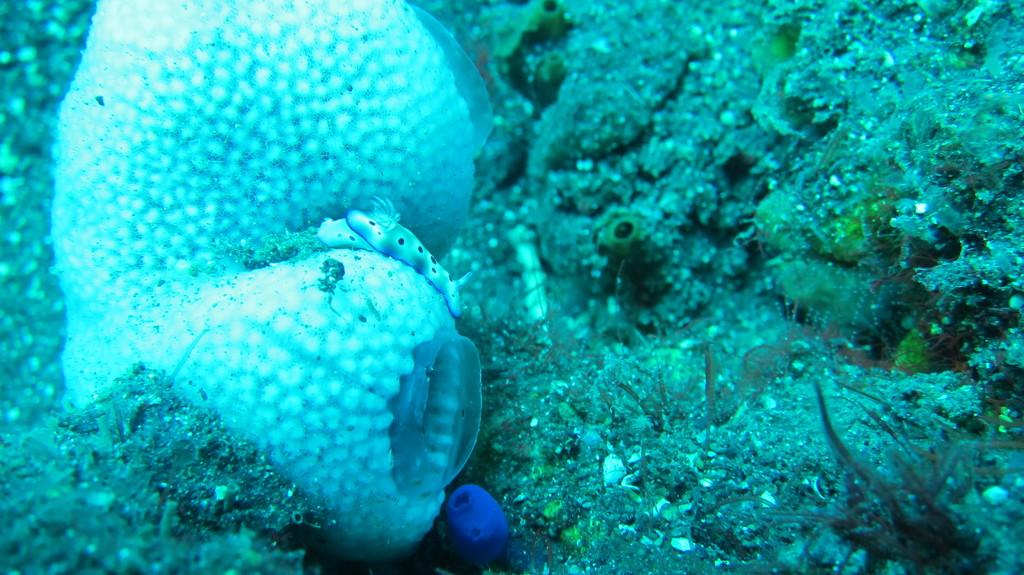What type of creature is in the image? There is a sea animal in the image. Can you describe the setting of the image? The environment in the image appears to be underwater. What type of fuel is being used by the hammer in the image? There is no hammer or fuel present in the image; it features a sea animal in an underwater environment. 